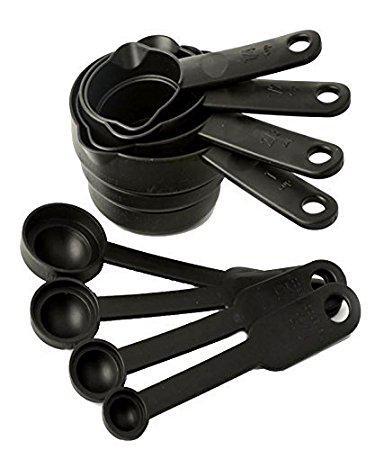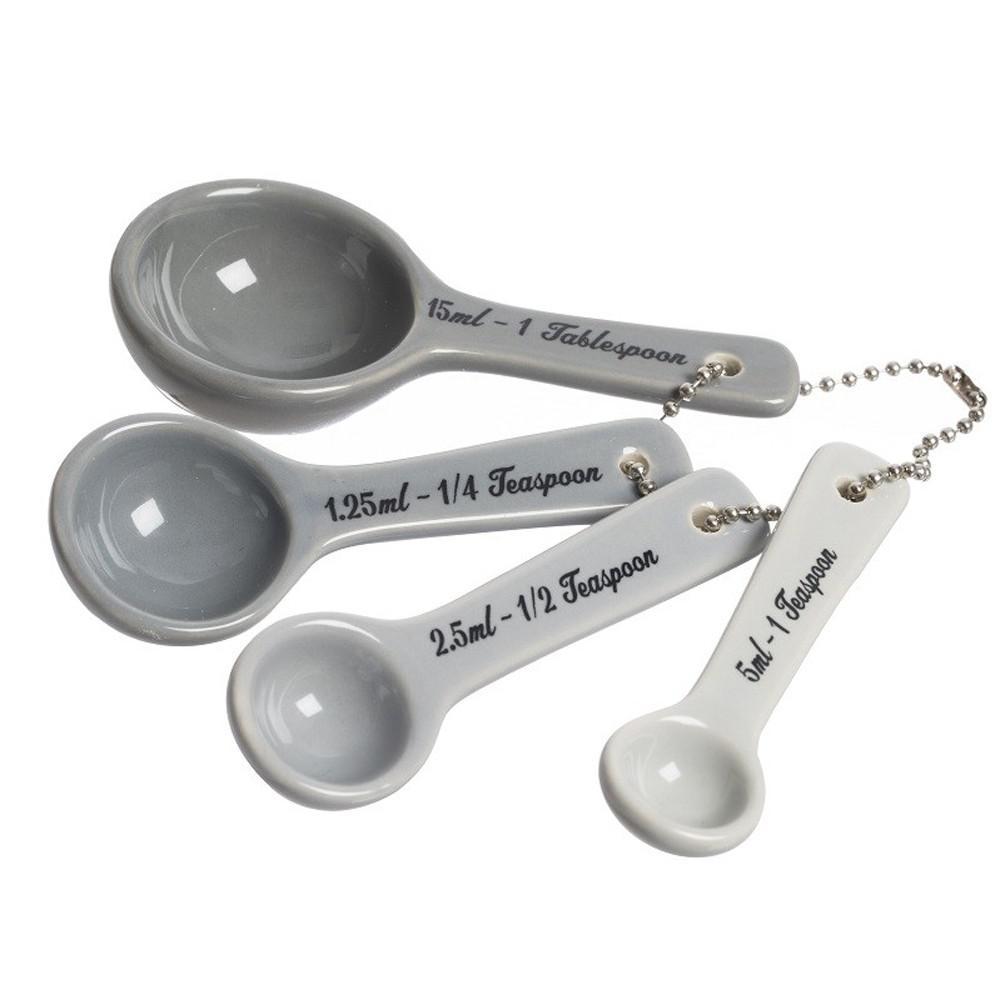The first image is the image on the left, the second image is the image on the right. Considering the images on both sides, is "The right image shows only one set of measuring utensils joined together." valid? Answer yes or no. Yes. 